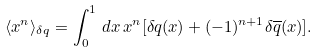Convert formula to latex. <formula><loc_0><loc_0><loc_500><loc_500>\langle x ^ { n } \rangle _ { \delta q } = \int _ { 0 } ^ { 1 } \, d x \, x ^ { n } [ \delta q ( x ) + ( - 1 ) ^ { n + 1 } \delta \overline { q } ( x ) ] .</formula> 